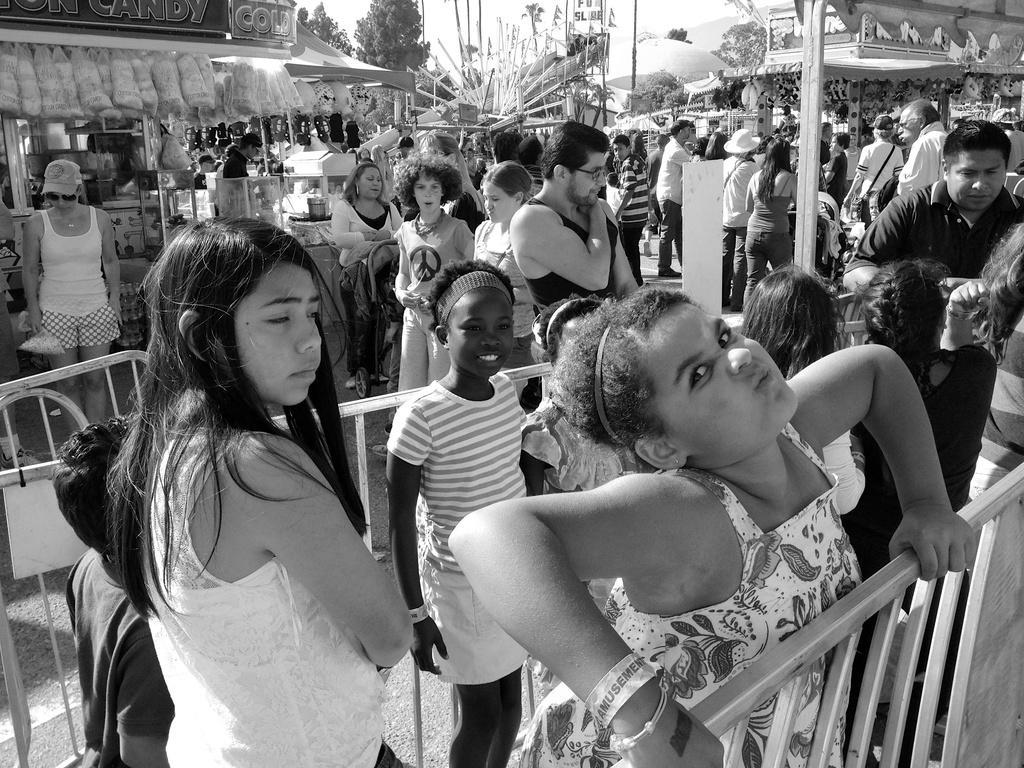Could you give a brief overview of what you see in this image? In this image there are a group of people standing, and in the foreground there is a railing and pole. In the background there are some stores, trees and some playing things and some other objects. 